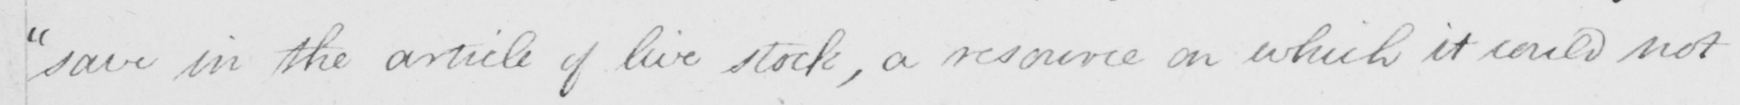Transcribe the text shown in this historical manuscript line. save in the article of live stock , a resource on which it could not 